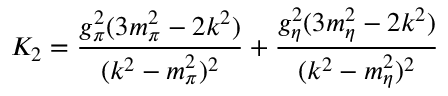Convert formula to latex. <formula><loc_0><loc_0><loc_500><loc_500>K _ { 2 } = \frac { g _ { \pi } ^ { 2 } ( 3 m _ { \pi } ^ { 2 } - 2 k ^ { 2 } ) } { ( k ^ { 2 } - m _ { \pi } ^ { 2 } ) ^ { 2 } } + \frac { g _ { \eta } ^ { 2 } ( 3 m _ { \eta } ^ { 2 } - 2 k ^ { 2 } ) } { ( k ^ { 2 } - m _ { \eta } ^ { 2 } ) ^ { 2 } }</formula> 